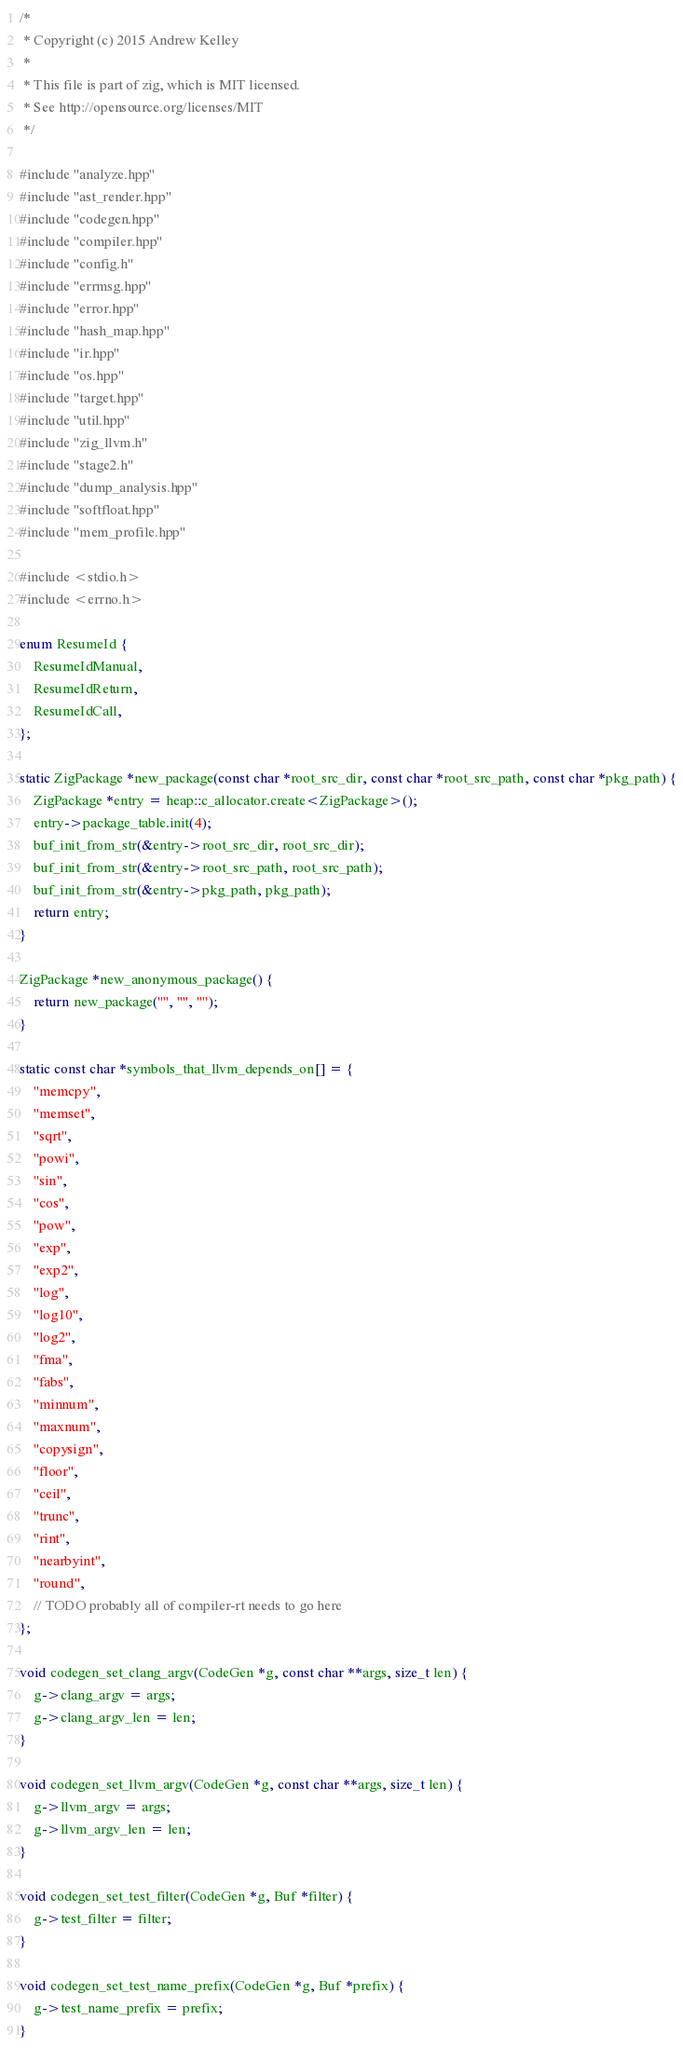<code> <loc_0><loc_0><loc_500><loc_500><_C++_>/*
 * Copyright (c) 2015 Andrew Kelley
 *
 * This file is part of zig, which is MIT licensed.
 * See http://opensource.org/licenses/MIT
 */

#include "analyze.hpp"
#include "ast_render.hpp"
#include "codegen.hpp"
#include "compiler.hpp"
#include "config.h"
#include "errmsg.hpp"
#include "error.hpp"
#include "hash_map.hpp"
#include "ir.hpp"
#include "os.hpp"
#include "target.hpp"
#include "util.hpp"
#include "zig_llvm.h"
#include "stage2.h"
#include "dump_analysis.hpp"
#include "softfloat.hpp"
#include "mem_profile.hpp"

#include <stdio.h>
#include <errno.h>

enum ResumeId {
    ResumeIdManual,
    ResumeIdReturn,
    ResumeIdCall,
};

static ZigPackage *new_package(const char *root_src_dir, const char *root_src_path, const char *pkg_path) {
    ZigPackage *entry = heap::c_allocator.create<ZigPackage>();
    entry->package_table.init(4);
    buf_init_from_str(&entry->root_src_dir, root_src_dir);
    buf_init_from_str(&entry->root_src_path, root_src_path);
    buf_init_from_str(&entry->pkg_path, pkg_path);
    return entry;
}

ZigPackage *new_anonymous_package() {
    return new_package("", "", "");
}

static const char *symbols_that_llvm_depends_on[] = {
    "memcpy",
    "memset",
    "sqrt",
    "powi",
    "sin",
    "cos",
    "pow",
    "exp",
    "exp2",
    "log",
    "log10",
    "log2",
    "fma",
    "fabs",
    "minnum",
    "maxnum",
    "copysign",
    "floor",
    "ceil",
    "trunc",
    "rint",
    "nearbyint",
    "round",
    // TODO probably all of compiler-rt needs to go here
};

void codegen_set_clang_argv(CodeGen *g, const char **args, size_t len) {
    g->clang_argv = args;
    g->clang_argv_len = len;
}

void codegen_set_llvm_argv(CodeGen *g, const char **args, size_t len) {
    g->llvm_argv = args;
    g->llvm_argv_len = len;
}

void codegen_set_test_filter(CodeGen *g, Buf *filter) {
    g->test_filter = filter;
}

void codegen_set_test_name_prefix(CodeGen *g, Buf *prefix) {
    g->test_name_prefix = prefix;
}
</code> 